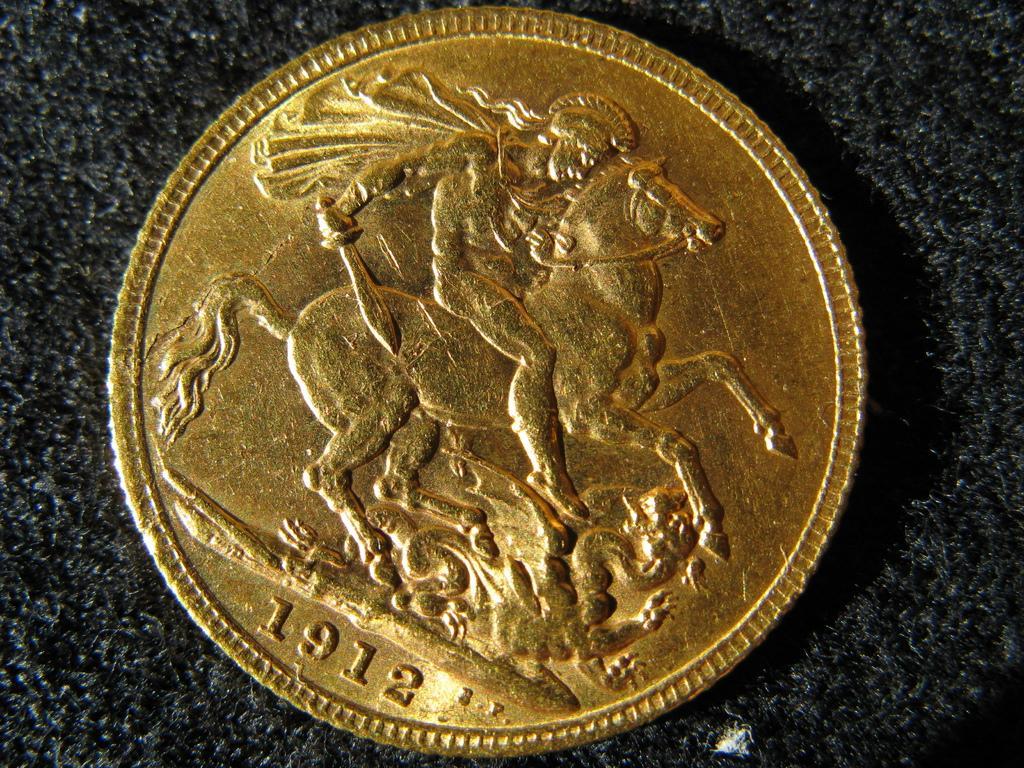Can you describe this image briefly? In this image we can see a coin with image and numbers. 